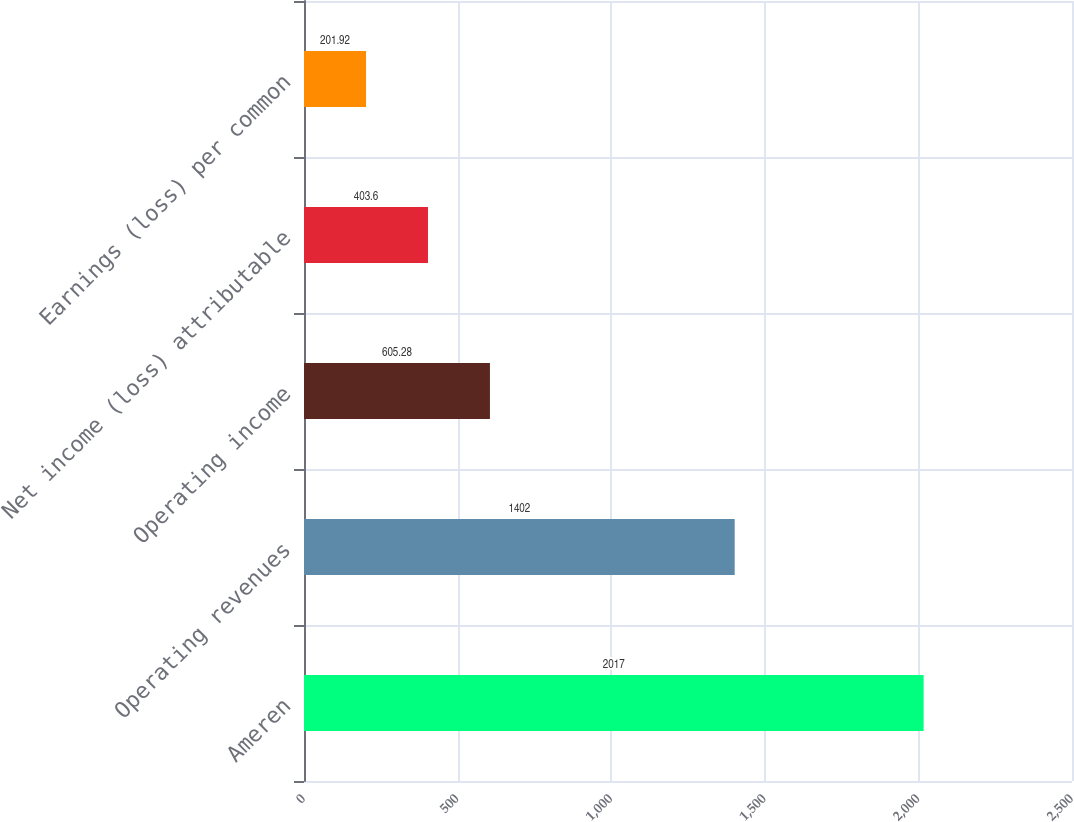Convert chart. <chart><loc_0><loc_0><loc_500><loc_500><bar_chart><fcel>Ameren<fcel>Operating revenues<fcel>Operating income<fcel>Net income (loss) attributable<fcel>Earnings (loss) per common<nl><fcel>2017<fcel>1402<fcel>605.28<fcel>403.6<fcel>201.92<nl></chart> 